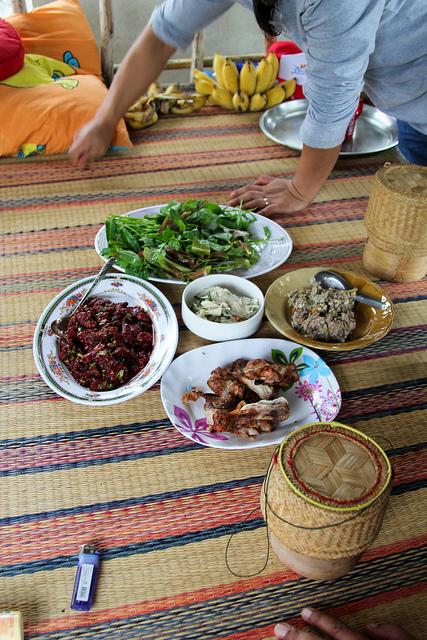What is closest to the person? salad 